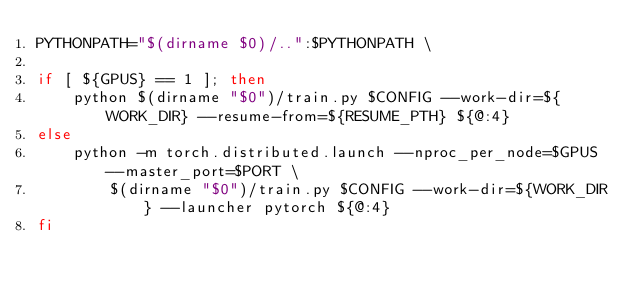Convert code to text. <code><loc_0><loc_0><loc_500><loc_500><_Bash_>PYTHONPATH="$(dirname $0)/..":$PYTHONPATH \

if [ ${GPUS} == 1 ]; then
    python $(dirname "$0")/train.py $CONFIG --work-dir=${WORK_DIR} --resume-from=${RESUME_PTH} ${@:4}
else
    python -m torch.distributed.launch --nproc_per_node=$GPUS --master_port=$PORT \
        $(dirname "$0")/train.py $CONFIG --work-dir=${WORK_DIR} --launcher pytorch ${@:4}
fi
</code> 